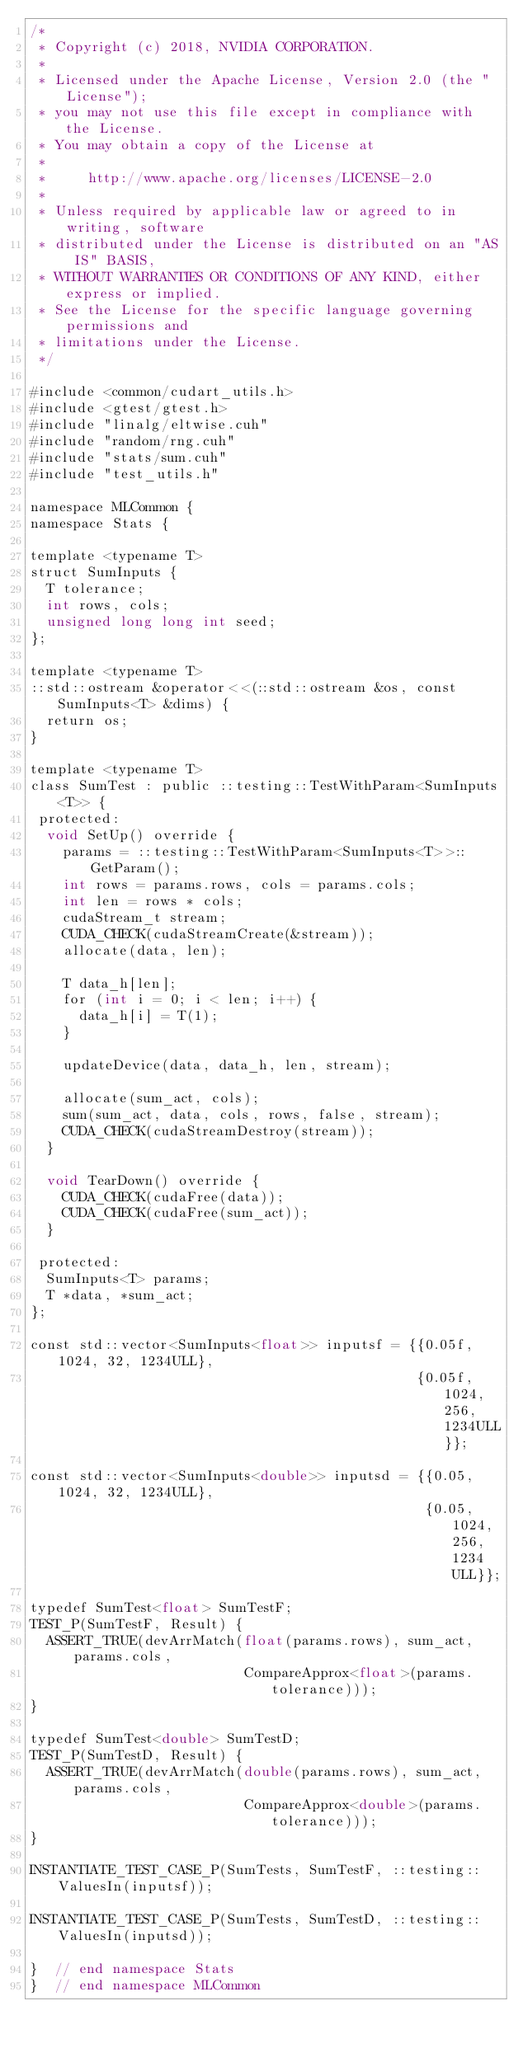<code> <loc_0><loc_0><loc_500><loc_500><_Cuda_>/*
 * Copyright (c) 2018, NVIDIA CORPORATION.
 *
 * Licensed under the Apache License, Version 2.0 (the "License");
 * you may not use this file except in compliance with the License.
 * You may obtain a copy of the License at
 *
 *     http://www.apache.org/licenses/LICENSE-2.0
 *
 * Unless required by applicable law or agreed to in writing, software
 * distributed under the License is distributed on an "AS IS" BASIS,
 * WITHOUT WARRANTIES OR CONDITIONS OF ANY KIND, either express or implied.
 * See the License for the specific language governing permissions and
 * limitations under the License.
 */

#include <common/cudart_utils.h>
#include <gtest/gtest.h>
#include "linalg/eltwise.cuh"
#include "random/rng.cuh"
#include "stats/sum.cuh"
#include "test_utils.h"

namespace MLCommon {
namespace Stats {

template <typename T>
struct SumInputs {
  T tolerance;
  int rows, cols;
  unsigned long long int seed;
};

template <typename T>
::std::ostream &operator<<(::std::ostream &os, const SumInputs<T> &dims) {
  return os;
}

template <typename T>
class SumTest : public ::testing::TestWithParam<SumInputs<T>> {
 protected:
  void SetUp() override {
    params = ::testing::TestWithParam<SumInputs<T>>::GetParam();
    int rows = params.rows, cols = params.cols;
    int len = rows * cols;
    cudaStream_t stream;
    CUDA_CHECK(cudaStreamCreate(&stream));
    allocate(data, len);

    T data_h[len];
    for (int i = 0; i < len; i++) {
      data_h[i] = T(1);
    }

    updateDevice(data, data_h, len, stream);

    allocate(sum_act, cols);
    sum(sum_act, data, cols, rows, false, stream);
    CUDA_CHECK(cudaStreamDestroy(stream));
  }

  void TearDown() override {
    CUDA_CHECK(cudaFree(data));
    CUDA_CHECK(cudaFree(sum_act));
  }

 protected:
  SumInputs<T> params;
  T *data, *sum_act;
};

const std::vector<SumInputs<float>> inputsf = {{0.05f, 1024, 32, 1234ULL},
                                               {0.05f, 1024, 256, 1234ULL}};

const std::vector<SumInputs<double>> inputsd = {{0.05, 1024, 32, 1234ULL},
                                                {0.05, 1024, 256, 1234ULL}};

typedef SumTest<float> SumTestF;
TEST_P(SumTestF, Result) {
  ASSERT_TRUE(devArrMatch(float(params.rows), sum_act, params.cols,
                          CompareApprox<float>(params.tolerance)));
}

typedef SumTest<double> SumTestD;
TEST_P(SumTestD, Result) {
  ASSERT_TRUE(devArrMatch(double(params.rows), sum_act, params.cols,
                          CompareApprox<double>(params.tolerance)));
}

INSTANTIATE_TEST_CASE_P(SumTests, SumTestF, ::testing::ValuesIn(inputsf));

INSTANTIATE_TEST_CASE_P(SumTests, SumTestD, ::testing::ValuesIn(inputsd));

}  // end namespace Stats
}  // end namespace MLCommon
</code> 